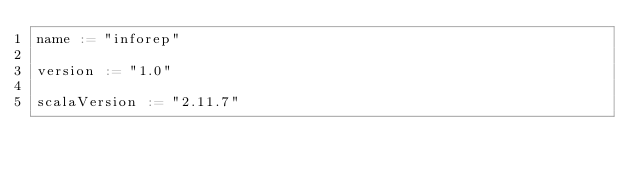Convert code to text. <code><loc_0><loc_0><loc_500><loc_500><_Scala_>name := "inforep"

version := "1.0"

scalaVersion := "2.11.7"
    </code> 